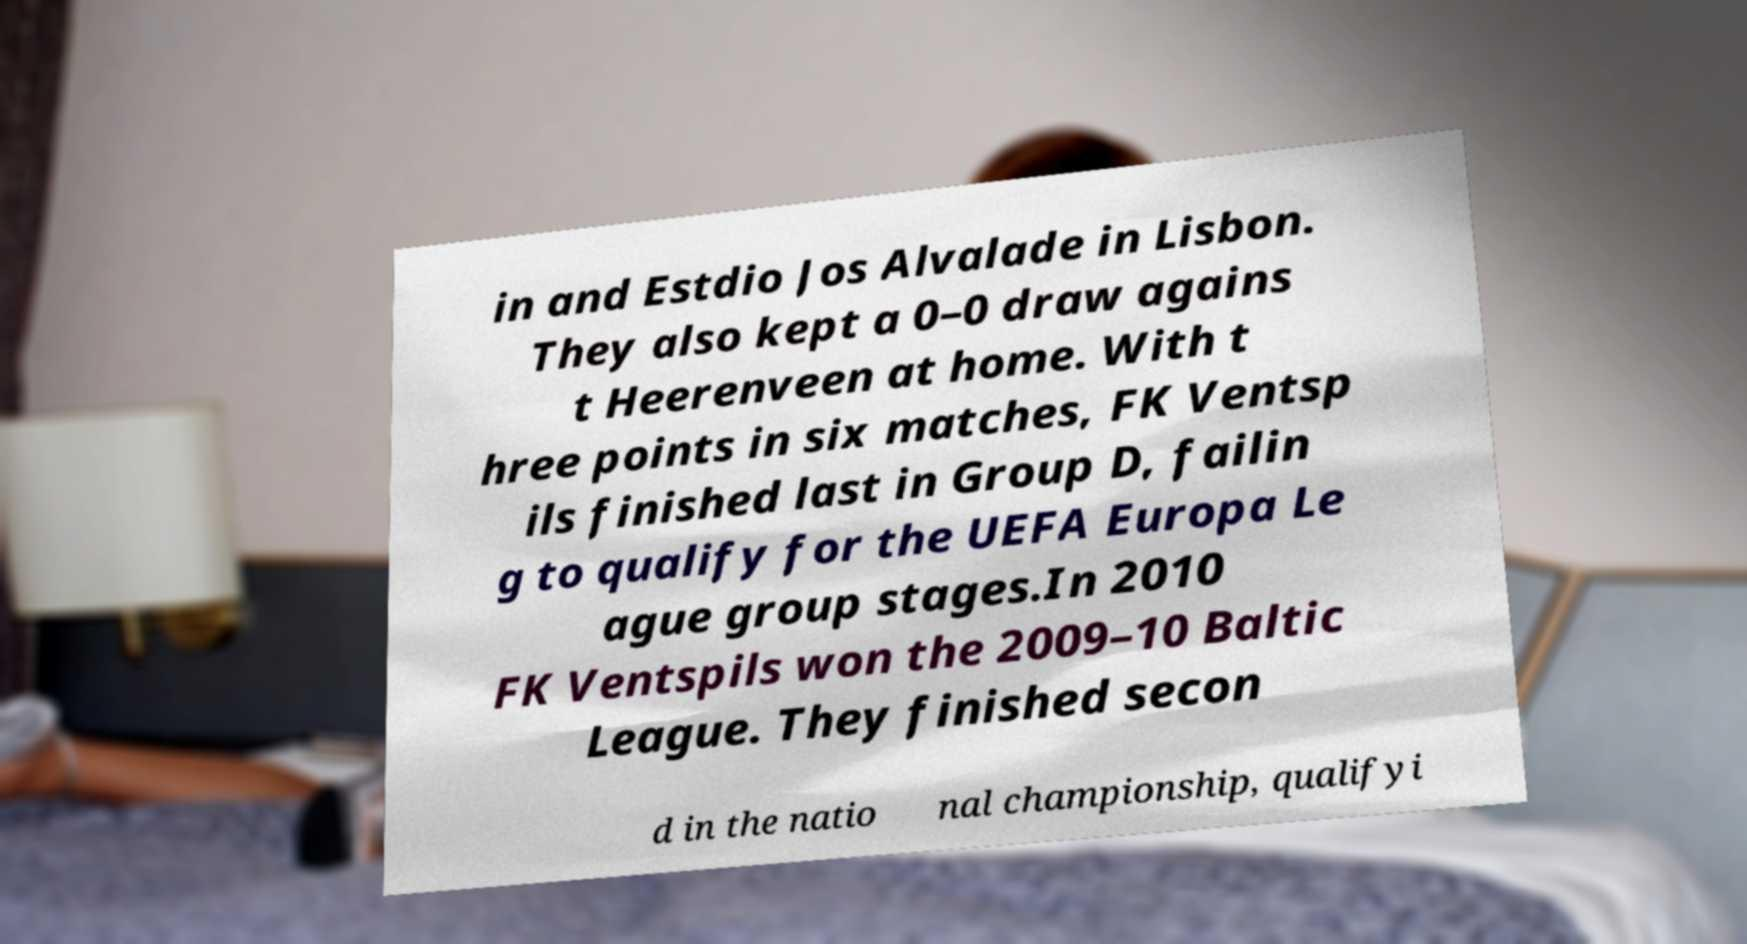Could you extract and type out the text from this image? in and Estdio Jos Alvalade in Lisbon. They also kept a 0–0 draw agains t Heerenveen at home. With t hree points in six matches, FK Ventsp ils finished last in Group D, failin g to qualify for the UEFA Europa Le ague group stages.In 2010 FK Ventspils won the 2009–10 Baltic League. They finished secon d in the natio nal championship, qualifyi 